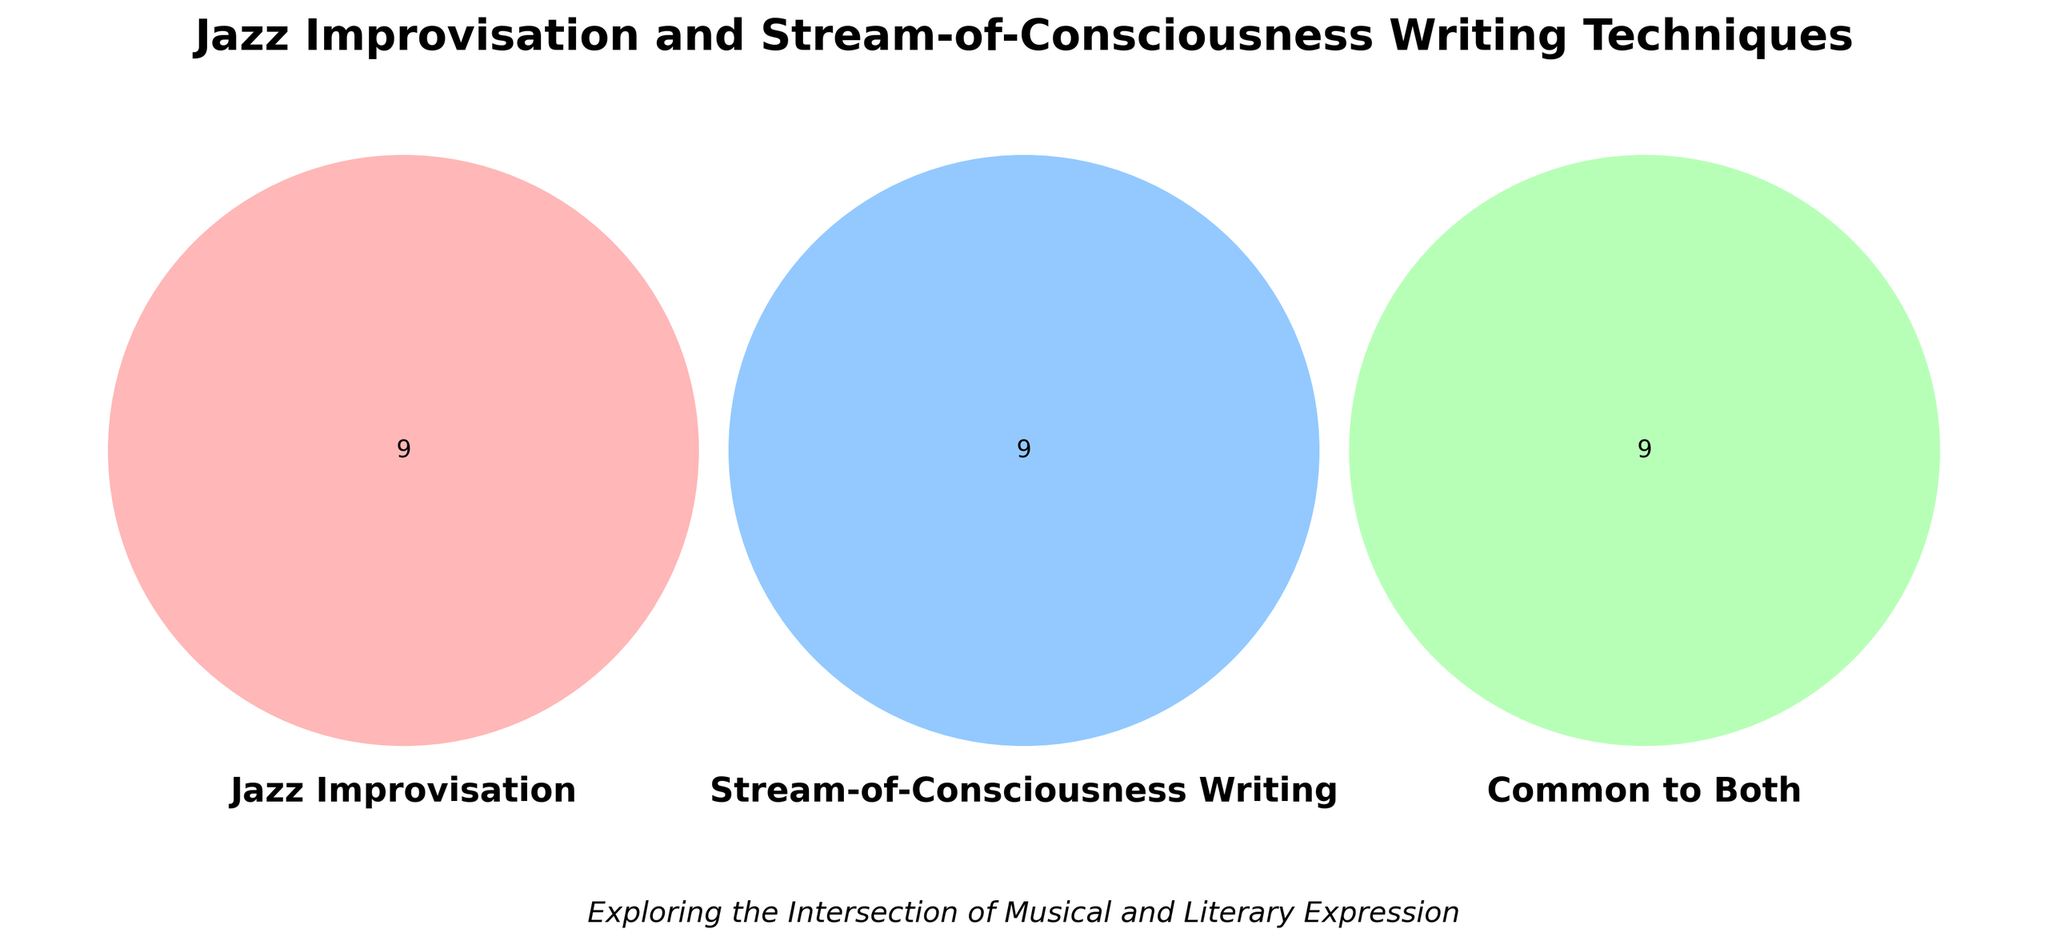What's the title of the Venn diagram? The title of the diagram is the text displayed prominently at the top of the figure. The title typically summarizes the main focus or topic of the Venn diagram.
Answer: Jazz Improvisation and Stream-of-Consciousness Writing Techniques What are the three main categories in the Venn diagram? The main categories are identified by the labels on each of the three overlapping circles in the diagram. These labels reflect the distinct groups being compared.
Answer: Jazz Improvisation, Stream-of-Consciousness Writing, Common to Both How many stylistic techniques are unique to Jazz improvisation? To find this information, count the number of unique techniques listed in the section of the Venn diagram corresponding only to Jazz improvisation (the left circle).
Answer: 9 Which category includes "Non-linear narrative"? Locate the label "Non-linear narrative" within the diagram. Since it's listed only in one section outside the intersecting areas, it's clear it belongs to a specific category.
Answer: Stream-of-Consciousness Writing What stylistic techniques are common to both Jazz improvisation and Stream-of-Consciousness writing? Look at the overlapping section where all three categories converge. The techniques listed there are common to both fields as per the Venn diagram.
Answer: Spontaneous expression, Emphasis on individual voice, Improvisation and fluidity, Unconventional structure, Emotional intensity, Subconscious exploration, Breaking traditional rules, Capturing the moment, Rhythmic patterns in language Compare the number of techniques solely unique to Stream-of-Consciousness writing and common to both categories. Which is greater? Count the techniques in both the "Stream-of-Consciousness Writing" category set and the intersection set. Compare the two counts.
Answer: Stream-of-Consciousness Writing How many stylistic techniques in total are presented in the Venn diagram? Sum all the unique techniques in each of the three sections of the Venn diagram, including those common to all categories.
Answer: 27 Which technique is placed in both Jazz and "Stream-of-Consciousness Writing" but not common to the third category? Analyze the intersections of Jazz and "Stream-of-Consciousness Writing" circles without including the middle section that is common to all three categories.
Answer: None Are there any techniques listed under the Jazz improvisation category that also appear in the Stream-of-Consciousness writing category? Verify if any techniques in the "Jazz Improvisation" section are repeated in the "Stream-of-Consciousness Writing" section without considering the common section.
Answer: No 